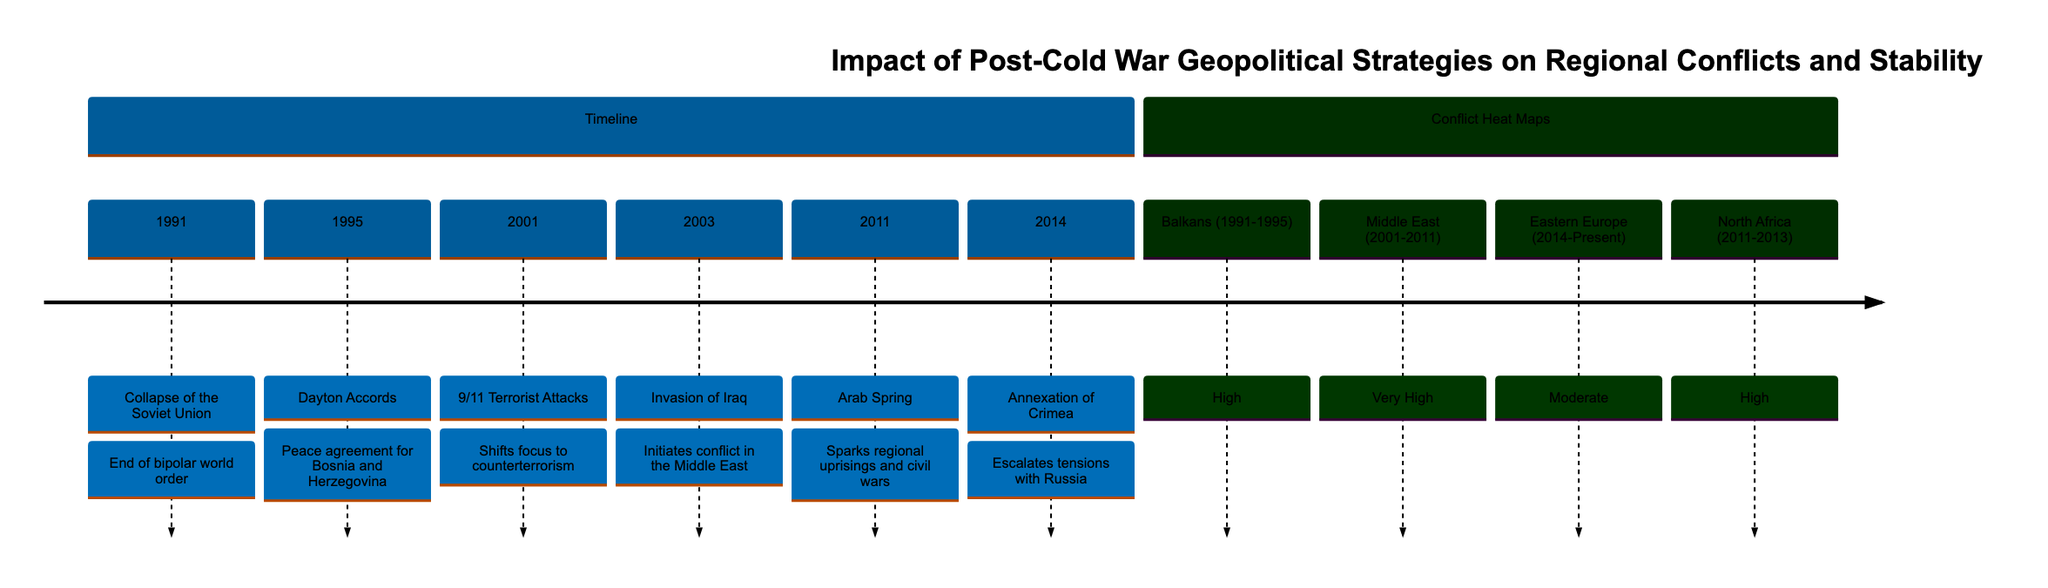What event marked the end of the bipolar world order? The diagram indicates that the "Collapse of the Soviet Union" in 1991 marked the end of the bipolar world order. This can be seen as the first event in the timeline section, which sets the stage for the geopolitical context following the Cold War.
Answer: Collapse of the Soviet Union What conflict had a "Very High" heat map rating? By examining the conflict heat map section of the diagram, it shows that the "Middle East (2001-2011)" is the region with a "Very High" heat map rating. This indicates significant conflict intensity during that time frame.
Answer: Very High How many major geopolitical events are depicted in the timeline? Counting the events listed in the timeline section reveals a total of six significant geopolitical events ranging from 1991 to 2014. Each event is marked chronologically, reflecting pivotal moments in post-Cold War geopolitics.
Answer: 6 What was the immediate geopolitical consequence of the 2003 invasion of Iraq? The diagram suggests that the invasion of Iraq in 2003 initiated conflict in the Middle East, which was a key turning point in regional stability. This information can be found in the event annotation beside the timeline marker for that year.
Answer: Initiates conflict in the Middle East Which region experienced high conflict during the Arab Spring? Referring to the conflict heat map, it is noted that "North Africa (2011-2013)" is identified as a region experiencing high levels of conflict during the time of the Arab Spring events. This aligns with the period associated with civil uprisings.
Answer: High What event shifted the focus of geopolitical strategies towards counterterrorism? According to the timeline in the diagram, the "9/11 Terrorist Attacks" in 2001 were pivotal in shifting the focus towards counterterrorism, as indicated by the annotations. This shift in strategy is a key element in understanding post-Cold War geopolitics.
Answer: 9/11 Terrorist Attacks Which event is associated with escalating tensions with Russia? The timeline indicates that the "Annexation of Crimea" in 2014 is directly related to escalating tensions with Russia, clearly marking a significant moment in regional conflicts post-Cold War. The annotation provides that context for understanding geopolitical dynamics.
Answer: Annexation of Crimea During which years did the Balkans experience high conflict? The conflict heat map section informs us that the Balkans experienced high conflict from 1991 to 1995, marking a critical period during and immediately after the Cold War. This timeframe is explicitly noted in the diagram.
Answer: 1991-1995 What geopolitical strategy was a response to the series of conflicts due to the Arab Spring? The diagram does not explicitly state a specific strategy in response to the Arab Spring; however, the implied focus would likely be on promoting stability and addressing the resultant civil wars and unrest in the affected regions. These political responses can be inferred from the context of conflict occurring from 2011 onward.
Answer: Promoting stability 